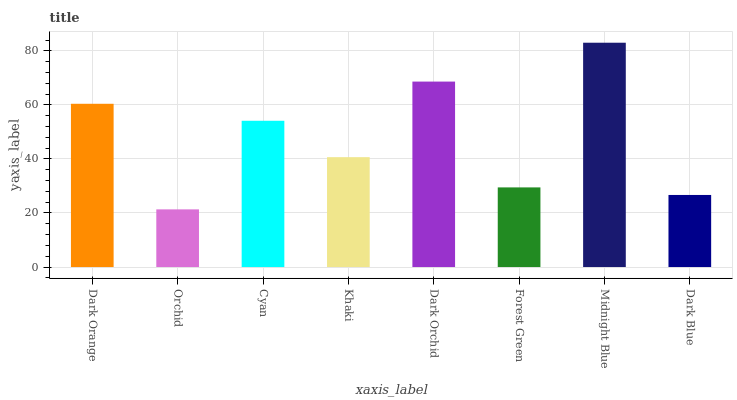Is Orchid the minimum?
Answer yes or no. Yes. Is Midnight Blue the maximum?
Answer yes or no. Yes. Is Cyan the minimum?
Answer yes or no. No. Is Cyan the maximum?
Answer yes or no. No. Is Cyan greater than Orchid?
Answer yes or no. Yes. Is Orchid less than Cyan?
Answer yes or no. Yes. Is Orchid greater than Cyan?
Answer yes or no. No. Is Cyan less than Orchid?
Answer yes or no. No. Is Cyan the high median?
Answer yes or no. Yes. Is Khaki the low median?
Answer yes or no. Yes. Is Khaki the high median?
Answer yes or no. No. Is Cyan the low median?
Answer yes or no. No. 